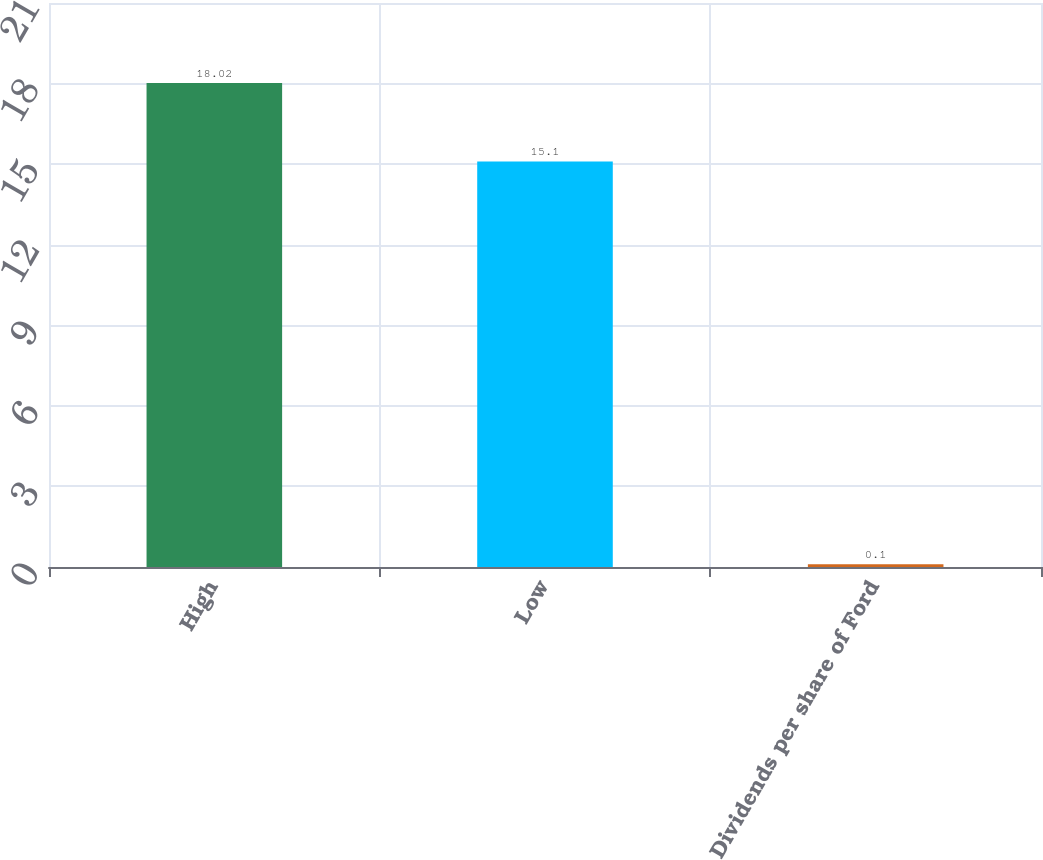Convert chart. <chart><loc_0><loc_0><loc_500><loc_500><bar_chart><fcel>High<fcel>Low<fcel>Dividends per share of Ford<nl><fcel>18.02<fcel>15.1<fcel>0.1<nl></chart> 